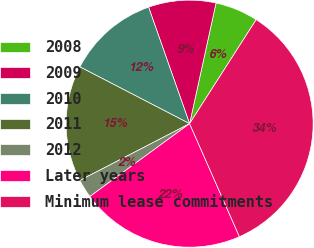<chart> <loc_0><loc_0><loc_500><loc_500><pie_chart><fcel>2008<fcel>2009<fcel>2010<fcel>2011<fcel>2012<fcel>Later years<fcel>Minimum lease commitments<nl><fcel>5.63%<fcel>8.82%<fcel>12.01%<fcel>15.2%<fcel>2.44%<fcel>21.57%<fcel>34.33%<nl></chart> 